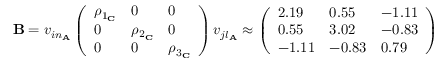<formula> <loc_0><loc_0><loc_500><loc_500>\begin{array} { r } { B = v _ { i n _ { A } } \left ( \begin{array} { l l l } { \rho _ { 1 _ { C } } } & { 0 } & { 0 } \\ { 0 } & { \rho _ { 2 _ { C } } } & { 0 } \\ { 0 } & { 0 } & { \rho _ { 3 _ { C } } } \end{array} \right ) v _ { j l _ { A } } \approx \left ( \begin{array} { l l l } { 2 . 1 9 } & { 0 . 5 5 } & { - 1 . 1 1 } \\ { 0 . 5 5 } & { 3 . 0 2 } & { - 0 . 8 3 } \\ { - 1 . 1 1 } & { - 0 . 8 3 } & { 0 . 7 9 } \end{array} \right ) } \end{array}</formula> 